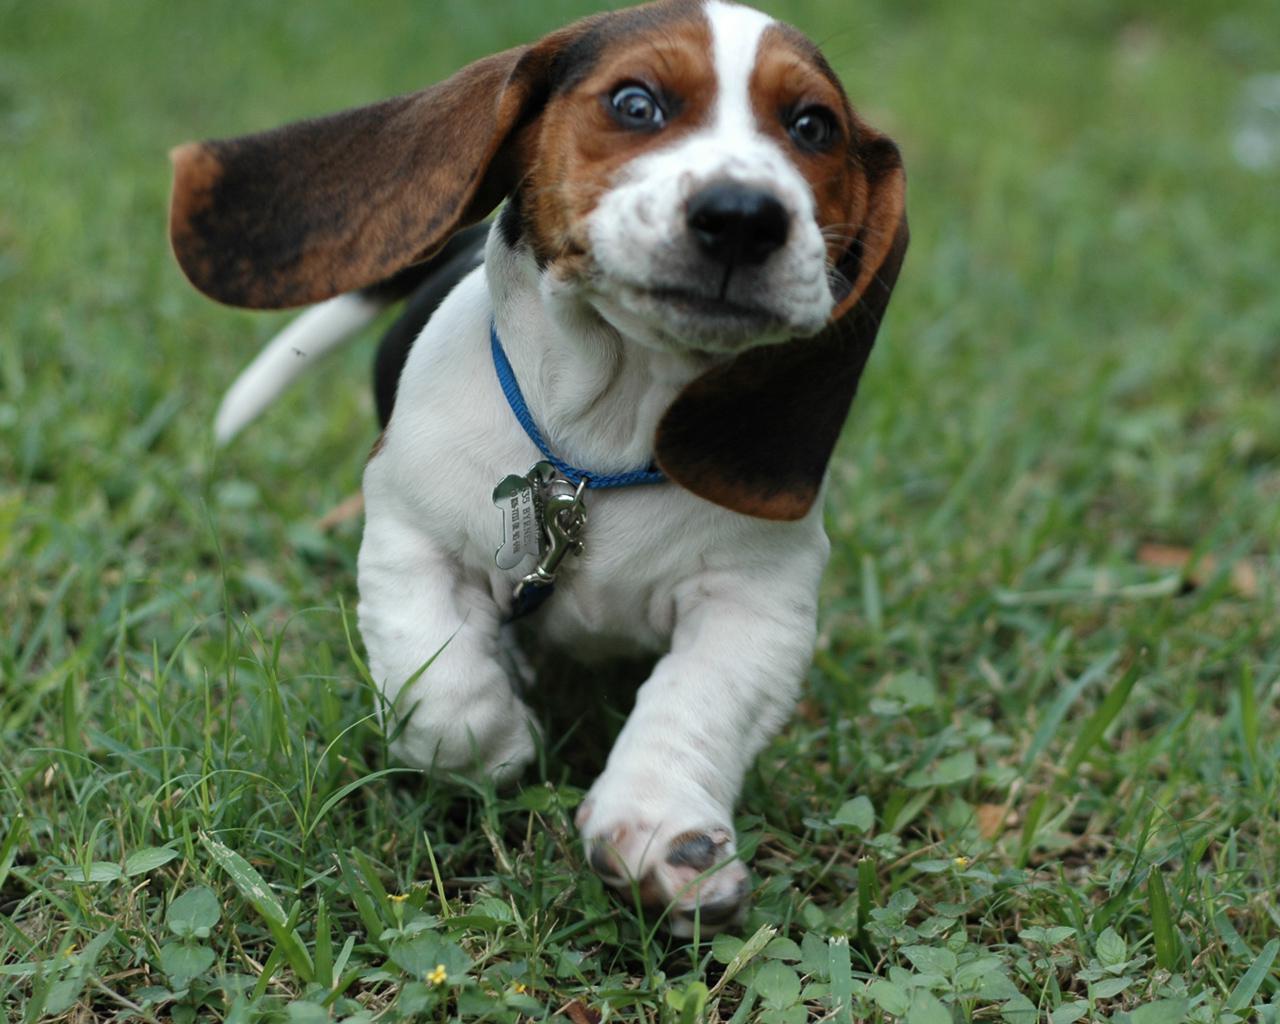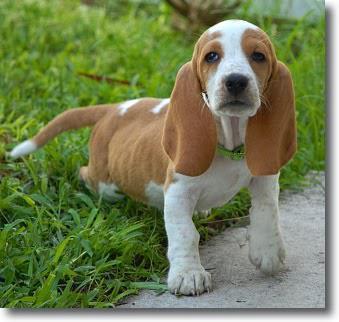The first image is the image on the left, the second image is the image on the right. Examine the images to the left and right. Is the description "One of the dog's front paws are not on the grass." accurate? Answer yes or no. Yes. The first image is the image on the left, the second image is the image on the right. Evaluate the accuracy of this statement regarding the images: "All dogs pictured have visible collars.". Is it true? Answer yes or no. Yes. 